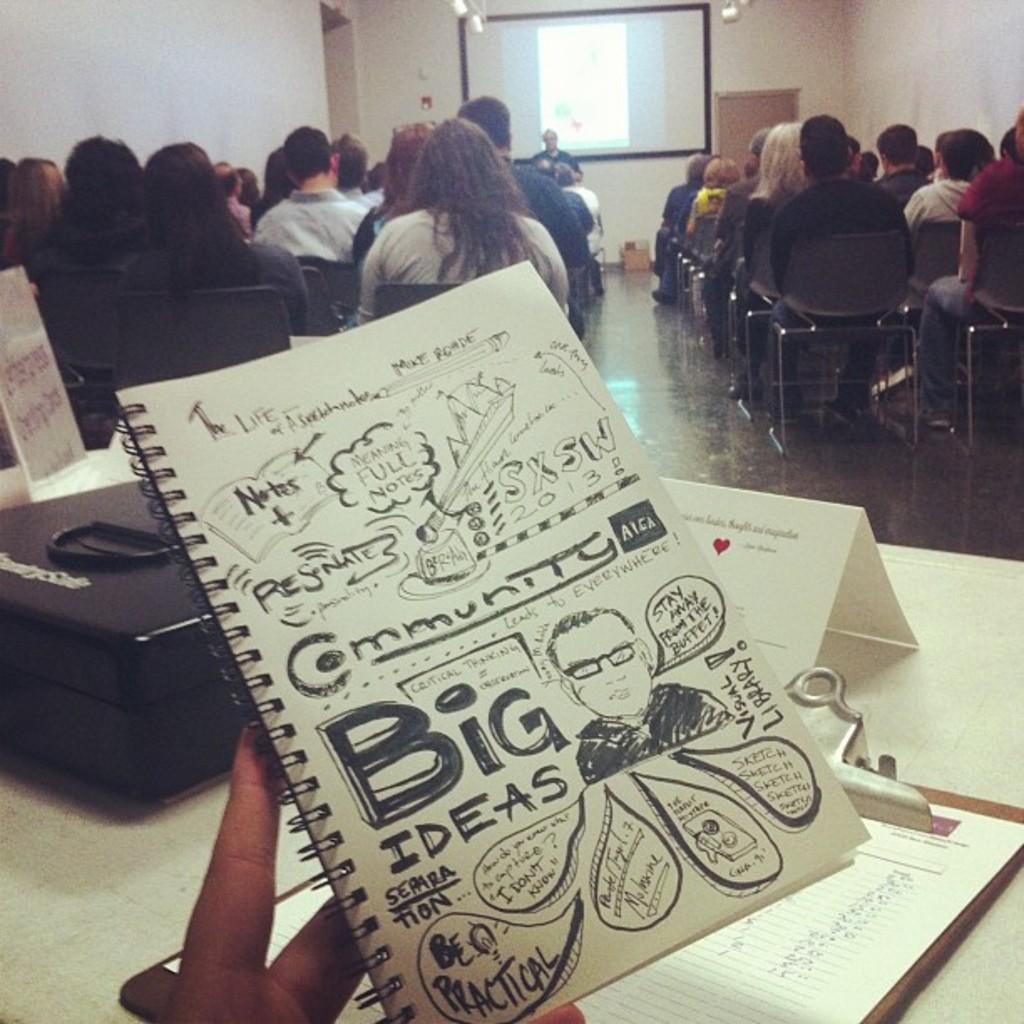In one or two sentences, can you explain what this image depicts? In the image we can see a book, on the book there is a text and a picture of a person. Here we can see exam pad, name plate, bag and there are people sitting on chairs, they are wearing clothes. Here we can see a floor and projected screen and there's even a person standing. 